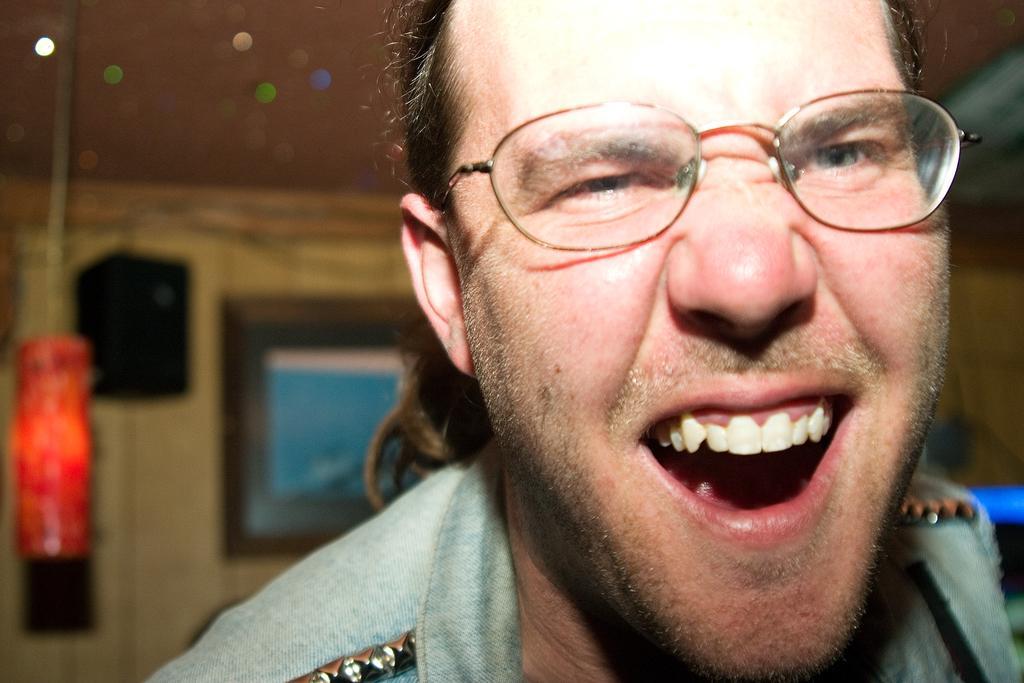Please provide a concise description of this image. In the picture I can see a man on the right side is wearing the spectacles on his eyes and there is a smile on his face. It is looking like a speaker on the left side. I can see a red color object on the left side. It is looking like a photo frame on the wall in the background. 